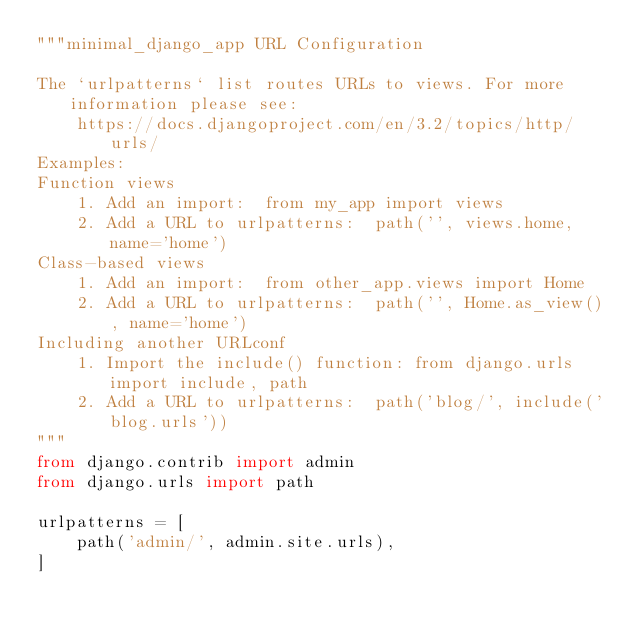Convert code to text. <code><loc_0><loc_0><loc_500><loc_500><_Python_>"""minimal_django_app URL Configuration

The `urlpatterns` list routes URLs to views. For more information please see:
    https://docs.djangoproject.com/en/3.2/topics/http/urls/
Examples:
Function views
    1. Add an import:  from my_app import views
    2. Add a URL to urlpatterns:  path('', views.home, name='home')
Class-based views
    1. Add an import:  from other_app.views import Home
    2. Add a URL to urlpatterns:  path('', Home.as_view(), name='home')
Including another URLconf
    1. Import the include() function: from django.urls import include, path
    2. Add a URL to urlpatterns:  path('blog/', include('blog.urls'))
"""
from django.contrib import admin
from django.urls import path

urlpatterns = [
    path('admin/', admin.site.urls),
]
</code> 